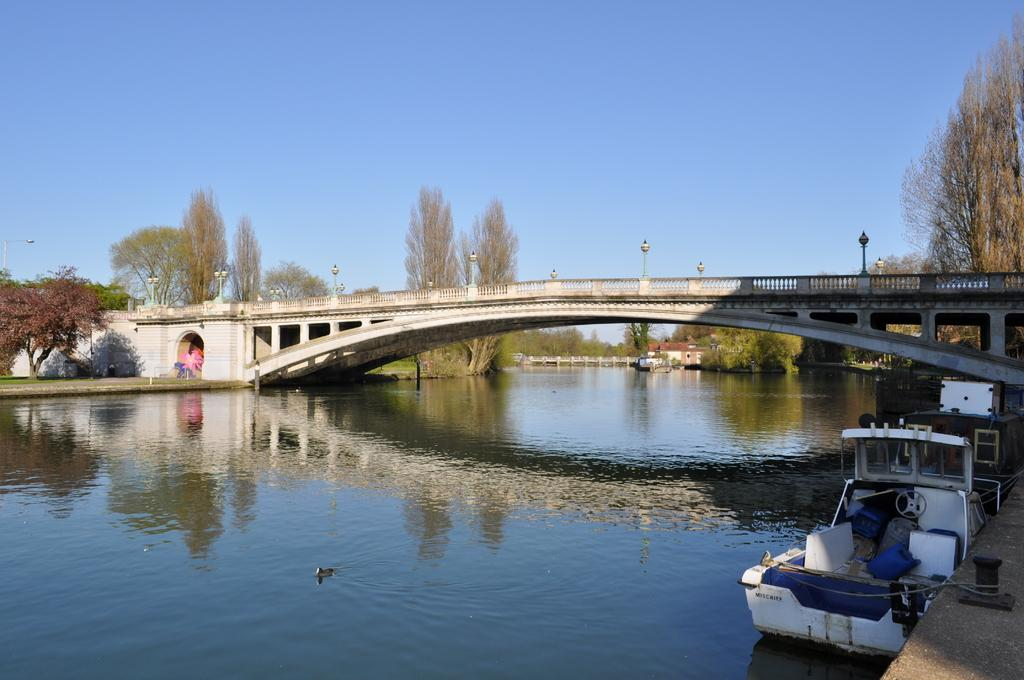What is present in the image that is related to water? There is water in the image, as well as boats. What structures can be seen in the image? There are bridges and buildings in the image. What type of vegetation is present in the image? There are trees and grass in the image. What can be seen in the background of the image? The sky is visible in the background of the image. What type of wool is being used to make the pies in the image? There are no pies or wool present in the image; it features water, boats, bridges, buildings, trees, grass, and a visible sky. 